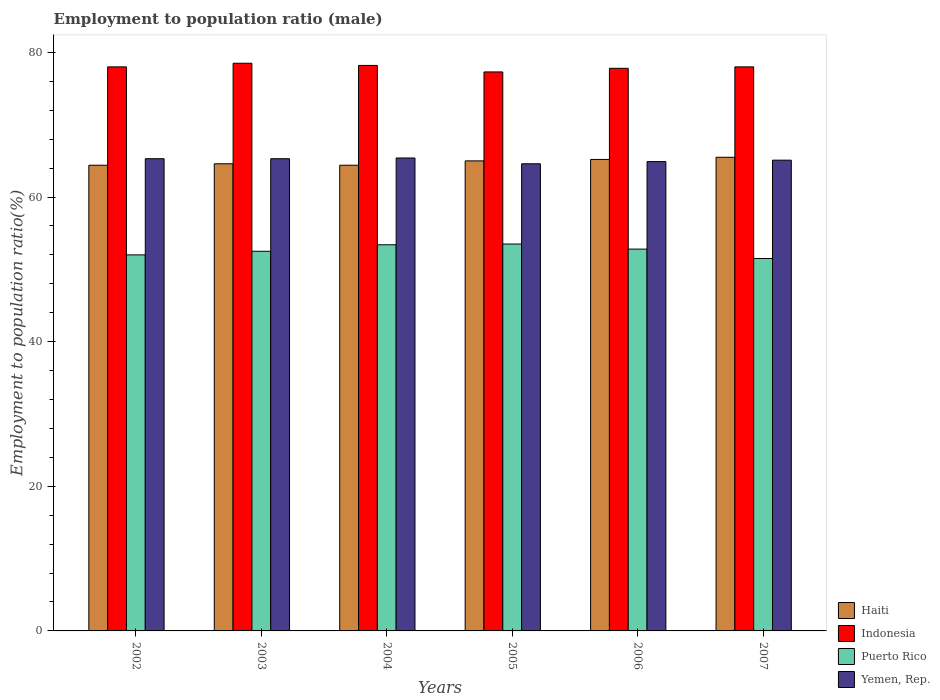How many different coloured bars are there?
Keep it short and to the point. 4. How many groups of bars are there?
Keep it short and to the point. 6. Are the number of bars per tick equal to the number of legend labels?
Provide a succinct answer. Yes. Are the number of bars on each tick of the X-axis equal?
Offer a terse response. Yes. How many bars are there on the 5th tick from the left?
Keep it short and to the point. 4. What is the label of the 3rd group of bars from the left?
Your response must be concise. 2004. In how many cases, is the number of bars for a given year not equal to the number of legend labels?
Keep it short and to the point. 0. What is the employment to population ratio in Indonesia in 2003?
Provide a succinct answer. 78.5. Across all years, what is the maximum employment to population ratio in Puerto Rico?
Offer a terse response. 53.5. Across all years, what is the minimum employment to population ratio in Yemen, Rep.?
Your answer should be very brief. 64.6. In which year was the employment to population ratio in Puerto Rico maximum?
Provide a succinct answer. 2005. What is the total employment to population ratio in Indonesia in the graph?
Make the answer very short. 467.8. What is the difference between the employment to population ratio in Indonesia in 2002 and that in 2004?
Make the answer very short. -0.2. What is the difference between the employment to population ratio in Indonesia in 2006 and the employment to population ratio in Yemen, Rep. in 2004?
Give a very brief answer. 12.4. What is the average employment to population ratio in Yemen, Rep. per year?
Keep it short and to the point. 65.1. In the year 2003, what is the difference between the employment to population ratio in Yemen, Rep. and employment to population ratio in Haiti?
Provide a short and direct response. 0.7. In how many years, is the employment to population ratio in Yemen, Rep. greater than 28 %?
Keep it short and to the point. 6. What is the ratio of the employment to population ratio in Indonesia in 2002 to that in 2006?
Give a very brief answer. 1. Is the difference between the employment to population ratio in Yemen, Rep. in 2003 and 2004 greater than the difference between the employment to population ratio in Haiti in 2003 and 2004?
Offer a very short reply. No. What is the difference between the highest and the second highest employment to population ratio in Puerto Rico?
Your answer should be compact. 0.1. What is the difference between the highest and the lowest employment to population ratio in Yemen, Rep.?
Keep it short and to the point. 0.8. Is it the case that in every year, the sum of the employment to population ratio in Yemen, Rep. and employment to population ratio in Puerto Rico is greater than the sum of employment to population ratio in Haiti and employment to population ratio in Indonesia?
Offer a terse response. No. What does the 3rd bar from the left in 2006 represents?
Your response must be concise. Puerto Rico. What does the 2nd bar from the right in 2002 represents?
Your response must be concise. Puerto Rico. How many bars are there?
Offer a very short reply. 24. How many years are there in the graph?
Your answer should be very brief. 6. Does the graph contain any zero values?
Offer a very short reply. No. Does the graph contain grids?
Make the answer very short. No. How are the legend labels stacked?
Ensure brevity in your answer.  Vertical. What is the title of the graph?
Provide a succinct answer. Employment to population ratio (male). What is the label or title of the X-axis?
Give a very brief answer. Years. What is the Employment to population ratio(%) of Haiti in 2002?
Your answer should be very brief. 64.4. What is the Employment to population ratio(%) in Indonesia in 2002?
Ensure brevity in your answer.  78. What is the Employment to population ratio(%) of Yemen, Rep. in 2002?
Make the answer very short. 65.3. What is the Employment to population ratio(%) in Haiti in 2003?
Your answer should be very brief. 64.6. What is the Employment to population ratio(%) in Indonesia in 2003?
Provide a short and direct response. 78.5. What is the Employment to population ratio(%) of Puerto Rico in 2003?
Your answer should be very brief. 52.5. What is the Employment to population ratio(%) of Yemen, Rep. in 2003?
Provide a short and direct response. 65.3. What is the Employment to population ratio(%) of Haiti in 2004?
Your answer should be compact. 64.4. What is the Employment to population ratio(%) of Indonesia in 2004?
Your answer should be compact. 78.2. What is the Employment to population ratio(%) in Puerto Rico in 2004?
Give a very brief answer. 53.4. What is the Employment to population ratio(%) in Yemen, Rep. in 2004?
Keep it short and to the point. 65.4. What is the Employment to population ratio(%) of Haiti in 2005?
Provide a short and direct response. 65. What is the Employment to population ratio(%) in Indonesia in 2005?
Make the answer very short. 77.3. What is the Employment to population ratio(%) of Puerto Rico in 2005?
Ensure brevity in your answer.  53.5. What is the Employment to population ratio(%) of Yemen, Rep. in 2005?
Your answer should be compact. 64.6. What is the Employment to population ratio(%) of Haiti in 2006?
Your answer should be compact. 65.2. What is the Employment to population ratio(%) of Indonesia in 2006?
Offer a very short reply. 77.8. What is the Employment to population ratio(%) of Puerto Rico in 2006?
Ensure brevity in your answer.  52.8. What is the Employment to population ratio(%) of Yemen, Rep. in 2006?
Ensure brevity in your answer.  64.9. What is the Employment to population ratio(%) of Haiti in 2007?
Your answer should be very brief. 65.5. What is the Employment to population ratio(%) of Indonesia in 2007?
Provide a succinct answer. 78. What is the Employment to population ratio(%) in Puerto Rico in 2007?
Ensure brevity in your answer.  51.5. What is the Employment to population ratio(%) of Yemen, Rep. in 2007?
Give a very brief answer. 65.1. Across all years, what is the maximum Employment to population ratio(%) in Haiti?
Your answer should be compact. 65.5. Across all years, what is the maximum Employment to population ratio(%) in Indonesia?
Provide a short and direct response. 78.5. Across all years, what is the maximum Employment to population ratio(%) of Puerto Rico?
Provide a short and direct response. 53.5. Across all years, what is the maximum Employment to population ratio(%) of Yemen, Rep.?
Offer a terse response. 65.4. Across all years, what is the minimum Employment to population ratio(%) in Haiti?
Provide a succinct answer. 64.4. Across all years, what is the minimum Employment to population ratio(%) in Indonesia?
Offer a terse response. 77.3. Across all years, what is the minimum Employment to population ratio(%) in Puerto Rico?
Your answer should be very brief. 51.5. Across all years, what is the minimum Employment to population ratio(%) of Yemen, Rep.?
Give a very brief answer. 64.6. What is the total Employment to population ratio(%) of Haiti in the graph?
Ensure brevity in your answer.  389.1. What is the total Employment to population ratio(%) of Indonesia in the graph?
Make the answer very short. 467.8. What is the total Employment to population ratio(%) in Puerto Rico in the graph?
Give a very brief answer. 315.7. What is the total Employment to population ratio(%) in Yemen, Rep. in the graph?
Give a very brief answer. 390.6. What is the difference between the Employment to population ratio(%) in Puerto Rico in 2002 and that in 2003?
Provide a succinct answer. -0.5. What is the difference between the Employment to population ratio(%) in Yemen, Rep. in 2002 and that in 2003?
Your answer should be compact. 0. What is the difference between the Employment to population ratio(%) in Haiti in 2002 and that in 2004?
Ensure brevity in your answer.  0. What is the difference between the Employment to population ratio(%) of Indonesia in 2002 and that in 2004?
Keep it short and to the point. -0.2. What is the difference between the Employment to population ratio(%) of Puerto Rico in 2002 and that in 2004?
Offer a terse response. -1.4. What is the difference between the Employment to population ratio(%) of Yemen, Rep. in 2002 and that in 2004?
Ensure brevity in your answer.  -0.1. What is the difference between the Employment to population ratio(%) in Haiti in 2002 and that in 2005?
Keep it short and to the point. -0.6. What is the difference between the Employment to population ratio(%) of Indonesia in 2002 and that in 2005?
Make the answer very short. 0.7. What is the difference between the Employment to population ratio(%) of Puerto Rico in 2002 and that in 2005?
Make the answer very short. -1.5. What is the difference between the Employment to population ratio(%) of Haiti in 2002 and that in 2006?
Ensure brevity in your answer.  -0.8. What is the difference between the Employment to population ratio(%) in Indonesia in 2002 and that in 2006?
Give a very brief answer. 0.2. What is the difference between the Employment to population ratio(%) in Puerto Rico in 2002 and that in 2007?
Make the answer very short. 0.5. What is the difference between the Employment to population ratio(%) of Yemen, Rep. in 2002 and that in 2007?
Provide a short and direct response. 0.2. What is the difference between the Employment to population ratio(%) of Haiti in 2003 and that in 2004?
Make the answer very short. 0.2. What is the difference between the Employment to population ratio(%) of Indonesia in 2003 and that in 2004?
Provide a short and direct response. 0.3. What is the difference between the Employment to population ratio(%) of Puerto Rico in 2003 and that in 2004?
Your answer should be compact. -0.9. What is the difference between the Employment to population ratio(%) of Yemen, Rep. in 2003 and that in 2004?
Offer a very short reply. -0.1. What is the difference between the Employment to population ratio(%) of Puerto Rico in 2003 and that in 2005?
Ensure brevity in your answer.  -1. What is the difference between the Employment to population ratio(%) in Yemen, Rep. in 2003 and that in 2005?
Make the answer very short. 0.7. What is the difference between the Employment to population ratio(%) in Indonesia in 2003 and that in 2006?
Offer a very short reply. 0.7. What is the difference between the Employment to population ratio(%) of Puerto Rico in 2003 and that in 2006?
Provide a succinct answer. -0.3. What is the difference between the Employment to population ratio(%) of Indonesia in 2003 and that in 2007?
Your response must be concise. 0.5. What is the difference between the Employment to population ratio(%) in Puerto Rico in 2003 and that in 2007?
Your response must be concise. 1. What is the difference between the Employment to population ratio(%) of Haiti in 2004 and that in 2005?
Provide a short and direct response. -0.6. What is the difference between the Employment to population ratio(%) in Puerto Rico in 2004 and that in 2005?
Make the answer very short. -0.1. What is the difference between the Employment to population ratio(%) of Yemen, Rep. in 2004 and that in 2005?
Keep it short and to the point. 0.8. What is the difference between the Employment to population ratio(%) of Haiti in 2004 and that in 2006?
Give a very brief answer. -0.8. What is the difference between the Employment to population ratio(%) in Puerto Rico in 2004 and that in 2006?
Provide a short and direct response. 0.6. What is the difference between the Employment to population ratio(%) of Yemen, Rep. in 2004 and that in 2006?
Provide a succinct answer. 0.5. What is the difference between the Employment to population ratio(%) of Indonesia in 2004 and that in 2007?
Offer a very short reply. 0.2. What is the difference between the Employment to population ratio(%) in Yemen, Rep. in 2004 and that in 2007?
Your response must be concise. 0.3. What is the difference between the Employment to population ratio(%) in Haiti in 2005 and that in 2006?
Your answer should be very brief. -0.2. What is the difference between the Employment to population ratio(%) of Puerto Rico in 2005 and that in 2006?
Offer a terse response. 0.7. What is the difference between the Employment to population ratio(%) of Indonesia in 2005 and that in 2007?
Provide a short and direct response. -0.7. What is the difference between the Employment to population ratio(%) in Puerto Rico in 2006 and that in 2007?
Offer a very short reply. 1.3. What is the difference between the Employment to population ratio(%) of Haiti in 2002 and the Employment to population ratio(%) of Indonesia in 2003?
Offer a very short reply. -14.1. What is the difference between the Employment to population ratio(%) in Indonesia in 2002 and the Employment to population ratio(%) in Puerto Rico in 2003?
Your response must be concise. 25.5. What is the difference between the Employment to population ratio(%) in Haiti in 2002 and the Employment to population ratio(%) in Indonesia in 2004?
Your response must be concise. -13.8. What is the difference between the Employment to population ratio(%) in Haiti in 2002 and the Employment to population ratio(%) in Yemen, Rep. in 2004?
Keep it short and to the point. -1. What is the difference between the Employment to population ratio(%) of Indonesia in 2002 and the Employment to population ratio(%) of Puerto Rico in 2004?
Provide a succinct answer. 24.6. What is the difference between the Employment to population ratio(%) of Indonesia in 2002 and the Employment to population ratio(%) of Yemen, Rep. in 2004?
Offer a terse response. 12.6. What is the difference between the Employment to population ratio(%) of Puerto Rico in 2002 and the Employment to population ratio(%) of Yemen, Rep. in 2004?
Provide a short and direct response. -13.4. What is the difference between the Employment to population ratio(%) of Puerto Rico in 2002 and the Employment to population ratio(%) of Yemen, Rep. in 2005?
Make the answer very short. -12.6. What is the difference between the Employment to population ratio(%) of Haiti in 2002 and the Employment to population ratio(%) of Yemen, Rep. in 2006?
Provide a succinct answer. -0.5. What is the difference between the Employment to population ratio(%) in Indonesia in 2002 and the Employment to population ratio(%) in Puerto Rico in 2006?
Provide a succinct answer. 25.2. What is the difference between the Employment to population ratio(%) in Haiti in 2002 and the Employment to population ratio(%) in Puerto Rico in 2007?
Offer a very short reply. 12.9. What is the difference between the Employment to population ratio(%) in Haiti in 2003 and the Employment to population ratio(%) in Indonesia in 2004?
Make the answer very short. -13.6. What is the difference between the Employment to population ratio(%) of Haiti in 2003 and the Employment to population ratio(%) of Puerto Rico in 2004?
Offer a very short reply. 11.2. What is the difference between the Employment to population ratio(%) in Haiti in 2003 and the Employment to population ratio(%) in Yemen, Rep. in 2004?
Your answer should be very brief. -0.8. What is the difference between the Employment to population ratio(%) in Indonesia in 2003 and the Employment to population ratio(%) in Puerto Rico in 2004?
Offer a very short reply. 25.1. What is the difference between the Employment to population ratio(%) in Haiti in 2003 and the Employment to population ratio(%) in Yemen, Rep. in 2005?
Ensure brevity in your answer.  0. What is the difference between the Employment to population ratio(%) in Puerto Rico in 2003 and the Employment to population ratio(%) in Yemen, Rep. in 2005?
Ensure brevity in your answer.  -12.1. What is the difference between the Employment to population ratio(%) of Haiti in 2003 and the Employment to population ratio(%) of Indonesia in 2006?
Make the answer very short. -13.2. What is the difference between the Employment to population ratio(%) of Haiti in 2003 and the Employment to population ratio(%) of Puerto Rico in 2006?
Keep it short and to the point. 11.8. What is the difference between the Employment to population ratio(%) of Haiti in 2003 and the Employment to population ratio(%) of Yemen, Rep. in 2006?
Provide a short and direct response. -0.3. What is the difference between the Employment to population ratio(%) in Indonesia in 2003 and the Employment to population ratio(%) in Puerto Rico in 2006?
Give a very brief answer. 25.7. What is the difference between the Employment to population ratio(%) in Indonesia in 2003 and the Employment to population ratio(%) in Yemen, Rep. in 2006?
Offer a very short reply. 13.6. What is the difference between the Employment to population ratio(%) in Haiti in 2003 and the Employment to population ratio(%) in Indonesia in 2007?
Give a very brief answer. -13.4. What is the difference between the Employment to population ratio(%) in Haiti in 2003 and the Employment to population ratio(%) in Yemen, Rep. in 2007?
Your response must be concise. -0.5. What is the difference between the Employment to population ratio(%) in Puerto Rico in 2003 and the Employment to population ratio(%) in Yemen, Rep. in 2007?
Your answer should be compact. -12.6. What is the difference between the Employment to population ratio(%) in Indonesia in 2004 and the Employment to population ratio(%) in Puerto Rico in 2005?
Offer a very short reply. 24.7. What is the difference between the Employment to population ratio(%) in Puerto Rico in 2004 and the Employment to population ratio(%) in Yemen, Rep. in 2005?
Provide a succinct answer. -11.2. What is the difference between the Employment to population ratio(%) of Haiti in 2004 and the Employment to population ratio(%) of Yemen, Rep. in 2006?
Keep it short and to the point. -0.5. What is the difference between the Employment to population ratio(%) in Indonesia in 2004 and the Employment to population ratio(%) in Puerto Rico in 2006?
Keep it short and to the point. 25.4. What is the difference between the Employment to population ratio(%) of Puerto Rico in 2004 and the Employment to population ratio(%) of Yemen, Rep. in 2006?
Your answer should be very brief. -11.5. What is the difference between the Employment to population ratio(%) in Haiti in 2004 and the Employment to population ratio(%) in Puerto Rico in 2007?
Ensure brevity in your answer.  12.9. What is the difference between the Employment to population ratio(%) of Indonesia in 2004 and the Employment to population ratio(%) of Puerto Rico in 2007?
Offer a very short reply. 26.7. What is the difference between the Employment to population ratio(%) in Haiti in 2005 and the Employment to population ratio(%) in Puerto Rico in 2006?
Ensure brevity in your answer.  12.2. What is the difference between the Employment to population ratio(%) of Haiti in 2005 and the Employment to population ratio(%) of Yemen, Rep. in 2006?
Ensure brevity in your answer.  0.1. What is the difference between the Employment to population ratio(%) of Indonesia in 2005 and the Employment to population ratio(%) of Yemen, Rep. in 2006?
Your response must be concise. 12.4. What is the difference between the Employment to population ratio(%) of Puerto Rico in 2005 and the Employment to population ratio(%) of Yemen, Rep. in 2006?
Provide a short and direct response. -11.4. What is the difference between the Employment to population ratio(%) of Haiti in 2005 and the Employment to population ratio(%) of Indonesia in 2007?
Give a very brief answer. -13. What is the difference between the Employment to population ratio(%) in Indonesia in 2005 and the Employment to population ratio(%) in Puerto Rico in 2007?
Provide a short and direct response. 25.8. What is the difference between the Employment to population ratio(%) in Haiti in 2006 and the Employment to population ratio(%) in Indonesia in 2007?
Provide a succinct answer. -12.8. What is the difference between the Employment to population ratio(%) of Haiti in 2006 and the Employment to population ratio(%) of Yemen, Rep. in 2007?
Your answer should be compact. 0.1. What is the difference between the Employment to population ratio(%) of Indonesia in 2006 and the Employment to population ratio(%) of Puerto Rico in 2007?
Offer a terse response. 26.3. What is the average Employment to population ratio(%) of Haiti per year?
Your answer should be compact. 64.85. What is the average Employment to population ratio(%) of Indonesia per year?
Ensure brevity in your answer.  77.97. What is the average Employment to population ratio(%) of Puerto Rico per year?
Offer a very short reply. 52.62. What is the average Employment to population ratio(%) of Yemen, Rep. per year?
Keep it short and to the point. 65.1. In the year 2002, what is the difference between the Employment to population ratio(%) of Haiti and Employment to population ratio(%) of Indonesia?
Your response must be concise. -13.6. In the year 2002, what is the difference between the Employment to population ratio(%) of Haiti and Employment to population ratio(%) of Puerto Rico?
Ensure brevity in your answer.  12.4. In the year 2002, what is the difference between the Employment to population ratio(%) of Haiti and Employment to population ratio(%) of Yemen, Rep.?
Offer a very short reply. -0.9. In the year 2002, what is the difference between the Employment to population ratio(%) in Puerto Rico and Employment to population ratio(%) in Yemen, Rep.?
Your response must be concise. -13.3. In the year 2003, what is the difference between the Employment to population ratio(%) of Haiti and Employment to population ratio(%) of Yemen, Rep.?
Make the answer very short. -0.7. In the year 2003, what is the difference between the Employment to population ratio(%) in Indonesia and Employment to population ratio(%) in Puerto Rico?
Ensure brevity in your answer.  26. In the year 2004, what is the difference between the Employment to population ratio(%) in Haiti and Employment to population ratio(%) in Indonesia?
Ensure brevity in your answer.  -13.8. In the year 2004, what is the difference between the Employment to population ratio(%) in Haiti and Employment to population ratio(%) in Yemen, Rep.?
Offer a terse response. -1. In the year 2004, what is the difference between the Employment to population ratio(%) of Indonesia and Employment to population ratio(%) of Puerto Rico?
Your response must be concise. 24.8. In the year 2004, what is the difference between the Employment to population ratio(%) in Indonesia and Employment to population ratio(%) in Yemen, Rep.?
Offer a very short reply. 12.8. In the year 2004, what is the difference between the Employment to population ratio(%) in Puerto Rico and Employment to population ratio(%) in Yemen, Rep.?
Your answer should be compact. -12. In the year 2005, what is the difference between the Employment to population ratio(%) of Haiti and Employment to population ratio(%) of Yemen, Rep.?
Your answer should be very brief. 0.4. In the year 2005, what is the difference between the Employment to population ratio(%) in Indonesia and Employment to population ratio(%) in Puerto Rico?
Give a very brief answer. 23.8. In the year 2005, what is the difference between the Employment to population ratio(%) of Indonesia and Employment to population ratio(%) of Yemen, Rep.?
Ensure brevity in your answer.  12.7. In the year 2005, what is the difference between the Employment to population ratio(%) in Puerto Rico and Employment to population ratio(%) in Yemen, Rep.?
Offer a very short reply. -11.1. In the year 2006, what is the difference between the Employment to population ratio(%) of Haiti and Employment to population ratio(%) of Puerto Rico?
Provide a short and direct response. 12.4. In the year 2006, what is the difference between the Employment to population ratio(%) in Indonesia and Employment to population ratio(%) in Yemen, Rep.?
Provide a succinct answer. 12.9. In the year 2007, what is the difference between the Employment to population ratio(%) of Haiti and Employment to population ratio(%) of Yemen, Rep.?
Keep it short and to the point. 0.4. In the year 2007, what is the difference between the Employment to population ratio(%) in Indonesia and Employment to population ratio(%) in Puerto Rico?
Give a very brief answer. 26.5. What is the ratio of the Employment to population ratio(%) in Haiti in 2002 to that in 2003?
Offer a very short reply. 1. What is the ratio of the Employment to population ratio(%) of Yemen, Rep. in 2002 to that in 2003?
Keep it short and to the point. 1. What is the ratio of the Employment to population ratio(%) of Haiti in 2002 to that in 2004?
Offer a terse response. 1. What is the ratio of the Employment to population ratio(%) of Puerto Rico in 2002 to that in 2004?
Provide a short and direct response. 0.97. What is the ratio of the Employment to population ratio(%) of Yemen, Rep. in 2002 to that in 2004?
Offer a very short reply. 1. What is the ratio of the Employment to population ratio(%) in Haiti in 2002 to that in 2005?
Offer a terse response. 0.99. What is the ratio of the Employment to population ratio(%) of Indonesia in 2002 to that in 2005?
Provide a succinct answer. 1.01. What is the ratio of the Employment to population ratio(%) of Puerto Rico in 2002 to that in 2005?
Your answer should be very brief. 0.97. What is the ratio of the Employment to population ratio(%) in Yemen, Rep. in 2002 to that in 2005?
Your answer should be compact. 1.01. What is the ratio of the Employment to population ratio(%) of Haiti in 2002 to that in 2006?
Keep it short and to the point. 0.99. What is the ratio of the Employment to population ratio(%) in Yemen, Rep. in 2002 to that in 2006?
Offer a very short reply. 1.01. What is the ratio of the Employment to population ratio(%) in Haiti in 2002 to that in 2007?
Your response must be concise. 0.98. What is the ratio of the Employment to population ratio(%) of Puerto Rico in 2002 to that in 2007?
Offer a terse response. 1.01. What is the ratio of the Employment to population ratio(%) of Yemen, Rep. in 2002 to that in 2007?
Ensure brevity in your answer.  1. What is the ratio of the Employment to population ratio(%) in Haiti in 2003 to that in 2004?
Offer a very short reply. 1. What is the ratio of the Employment to population ratio(%) in Indonesia in 2003 to that in 2004?
Your response must be concise. 1. What is the ratio of the Employment to population ratio(%) of Puerto Rico in 2003 to that in 2004?
Make the answer very short. 0.98. What is the ratio of the Employment to population ratio(%) of Yemen, Rep. in 2003 to that in 2004?
Your answer should be compact. 1. What is the ratio of the Employment to population ratio(%) of Haiti in 2003 to that in 2005?
Give a very brief answer. 0.99. What is the ratio of the Employment to population ratio(%) of Indonesia in 2003 to that in 2005?
Give a very brief answer. 1.02. What is the ratio of the Employment to population ratio(%) of Puerto Rico in 2003 to that in 2005?
Provide a short and direct response. 0.98. What is the ratio of the Employment to population ratio(%) of Yemen, Rep. in 2003 to that in 2005?
Keep it short and to the point. 1.01. What is the ratio of the Employment to population ratio(%) in Haiti in 2003 to that in 2006?
Provide a short and direct response. 0.99. What is the ratio of the Employment to population ratio(%) in Haiti in 2003 to that in 2007?
Make the answer very short. 0.99. What is the ratio of the Employment to population ratio(%) in Indonesia in 2003 to that in 2007?
Provide a succinct answer. 1.01. What is the ratio of the Employment to population ratio(%) in Puerto Rico in 2003 to that in 2007?
Your answer should be very brief. 1.02. What is the ratio of the Employment to population ratio(%) of Yemen, Rep. in 2003 to that in 2007?
Ensure brevity in your answer.  1. What is the ratio of the Employment to population ratio(%) in Indonesia in 2004 to that in 2005?
Provide a short and direct response. 1.01. What is the ratio of the Employment to population ratio(%) in Puerto Rico in 2004 to that in 2005?
Keep it short and to the point. 1. What is the ratio of the Employment to population ratio(%) of Yemen, Rep. in 2004 to that in 2005?
Provide a short and direct response. 1.01. What is the ratio of the Employment to population ratio(%) of Haiti in 2004 to that in 2006?
Your answer should be very brief. 0.99. What is the ratio of the Employment to population ratio(%) in Puerto Rico in 2004 to that in 2006?
Provide a short and direct response. 1.01. What is the ratio of the Employment to population ratio(%) of Yemen, Rep. in 2004 to that in 2006?
Your answer should be compact. 1.01. What is the ratio of the Employment to population ratio(%) in Haiti in 2004 to that in 2007?
Offer a very short reply. 0.98. What is the ratio of the Employment to population ratio(%) in Indonesia in 2004 to that in 2007?
Your answer should be compact. 1. What is the ratio of the Employment to population ratio(%) in Puerto Rico in 2004 to that in 2007?
Provide a succinct answer. 1.04. What is the ratio of the Employment to population ratio(%) in Yemen, Rep. in 2004 to that in 2007?
Your answer should be compact. 1. What is the ratio of the Employment to population ratio(%) in Haiti in 2005 to that in 2006?
Offer a terse response. 1. What is the ratio of the Employment to population ratio(%) in Puerto Rico in 2005 to that in 2006?
Keep it short and to the point. 1.01. What is the ratio of the Employment to population ratio(%) in Yemen, Rep. in 2005 to that in 2006?
Keep it short and to the point. 1. What is the ratio of the Employment to population ratio(%) of Haiti in 2005 to that in 2007?
Provide a short and direct response. 0.99. What is the ratio of the Employment to population ratio(%) in Indonesia in 2005 to that in 2007?
Your answer should be very brief. 0.99. What is the ratio of the Employment to population ratio(%) in Puerto Rico in 2005 to that in 2007?
Make the answer very short. 1.04. What is the ratio of the Employment to population ratio(%) of Yemen, Rep. in 2005 to that in 2007?
Provide a short and direct response. 0.99. What is the ratio of the Employment to population ratio(%) in Puerto Rico in 2006 to that in 2007?
Your answer should be very brief. 1.03. What is the ratio of the Employment to population ratio(%) in Yemen, Rep. in 2006 to that in 2007?
Give a very brief answer. 1. What is the difference between the highest and the second highest Employment to population ratio(%) of Haiti?
Offer a terse response. 0.3. What is the difference between the highest and the second highest Employment to population ratio(%) of Indonesia?
Offer a terse response. 0.3. What is the difference between the highest and the second highest Employment to population ratio(%) of Puerto Rico?
Offer a very short reply. 0.1. What is the difference between the highest and the second highest Employment to population ratio(%) in Yemen, Rep.?
Your answer should be very brief. 0.1. What is the difference between the highest and the lowest Employment to population ratio(%) of Indonesia?
Your answer should be compact. 1.2. 